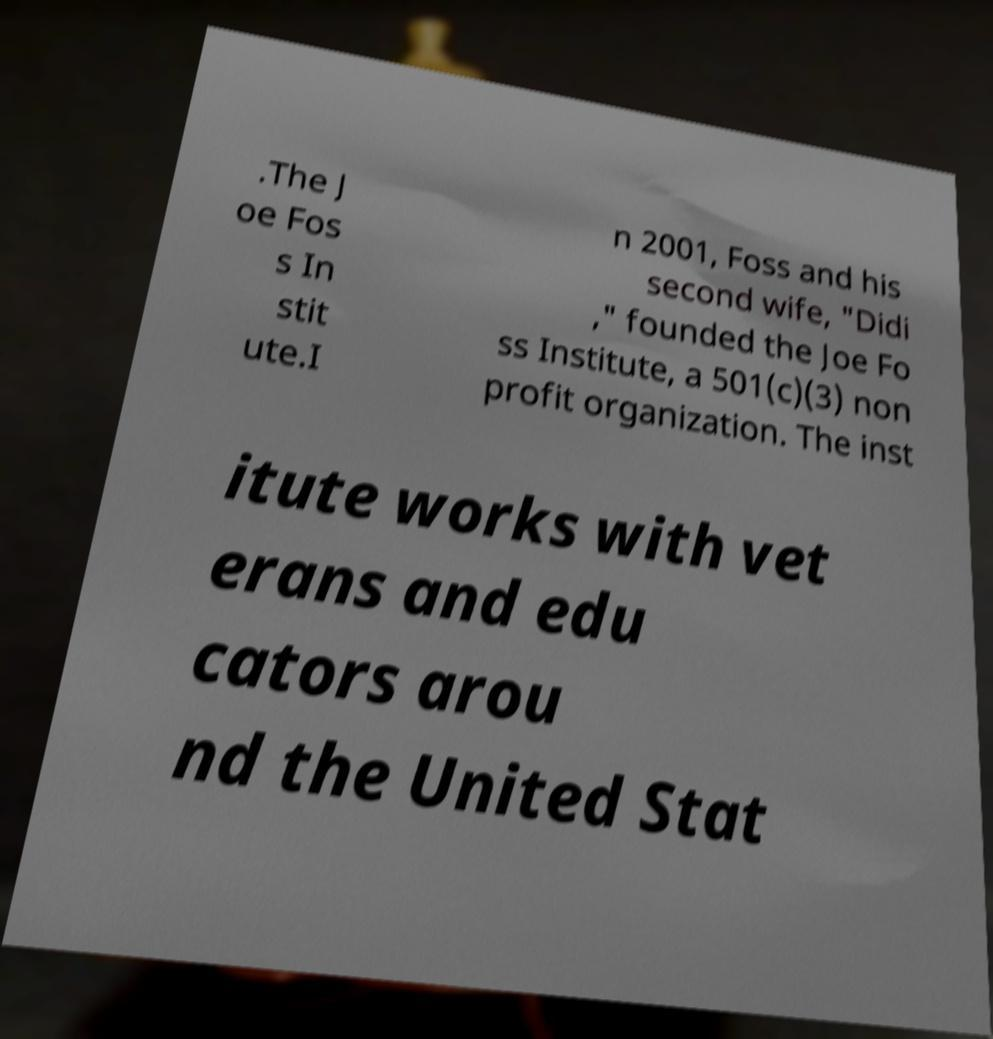What messages or text are displayed in this image? I need them in a readable, typed format. .The J oe Fos s In stit ute.I n 2001, Foss and his second wife, "Didi ," founded the Joe Fo ss Institute, a 501(c)(3) non profit organization. The inst itute works with vet erans and edu cators arou nd the United Stat 